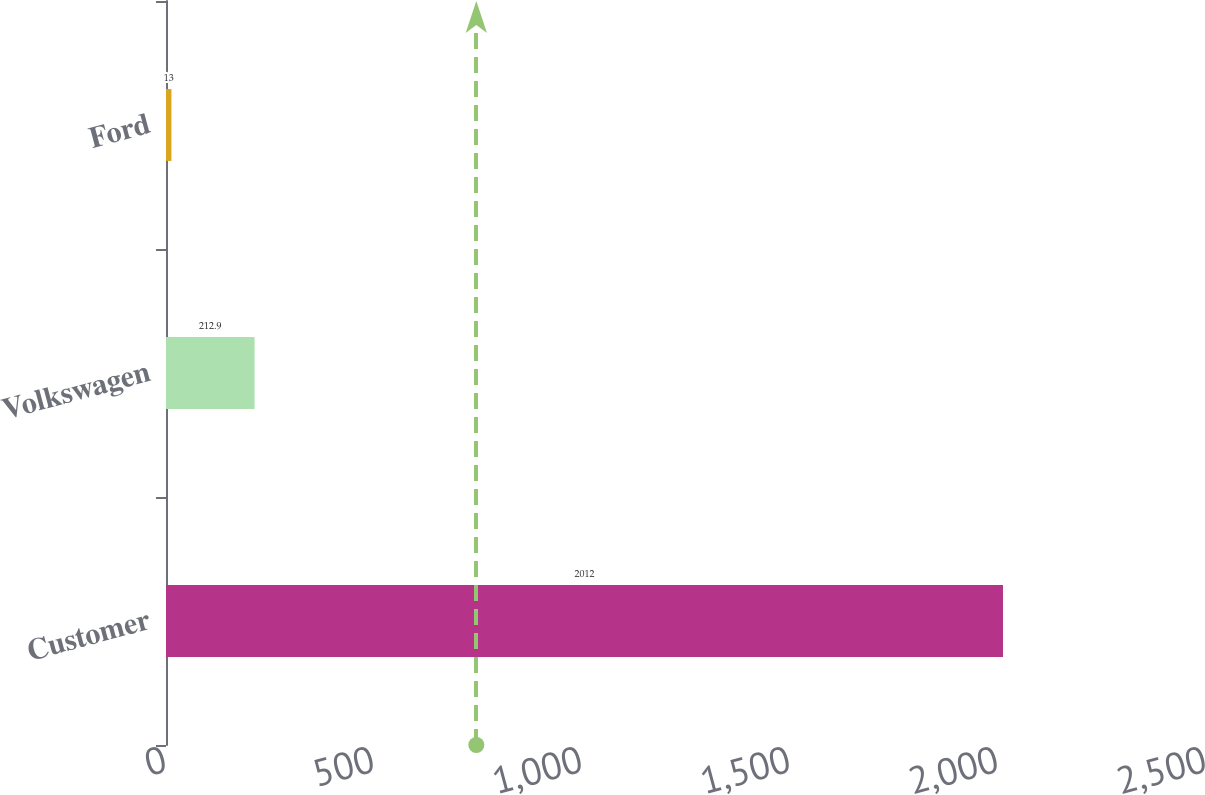<chart> <loc_0><loc_0><loc_500><loc_500><bar_chart><fcel>Customer<fcel>Volkswagen<fcel>Ford<nl><fcel>2012<fcel>212.9<fcel>13<nl></chart> 